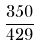Convert formula to latex. <formula><loc_0><loc_0><loc_500><loc_500>\frac { 3 5 0 } { 4 2 9 }</formula> 